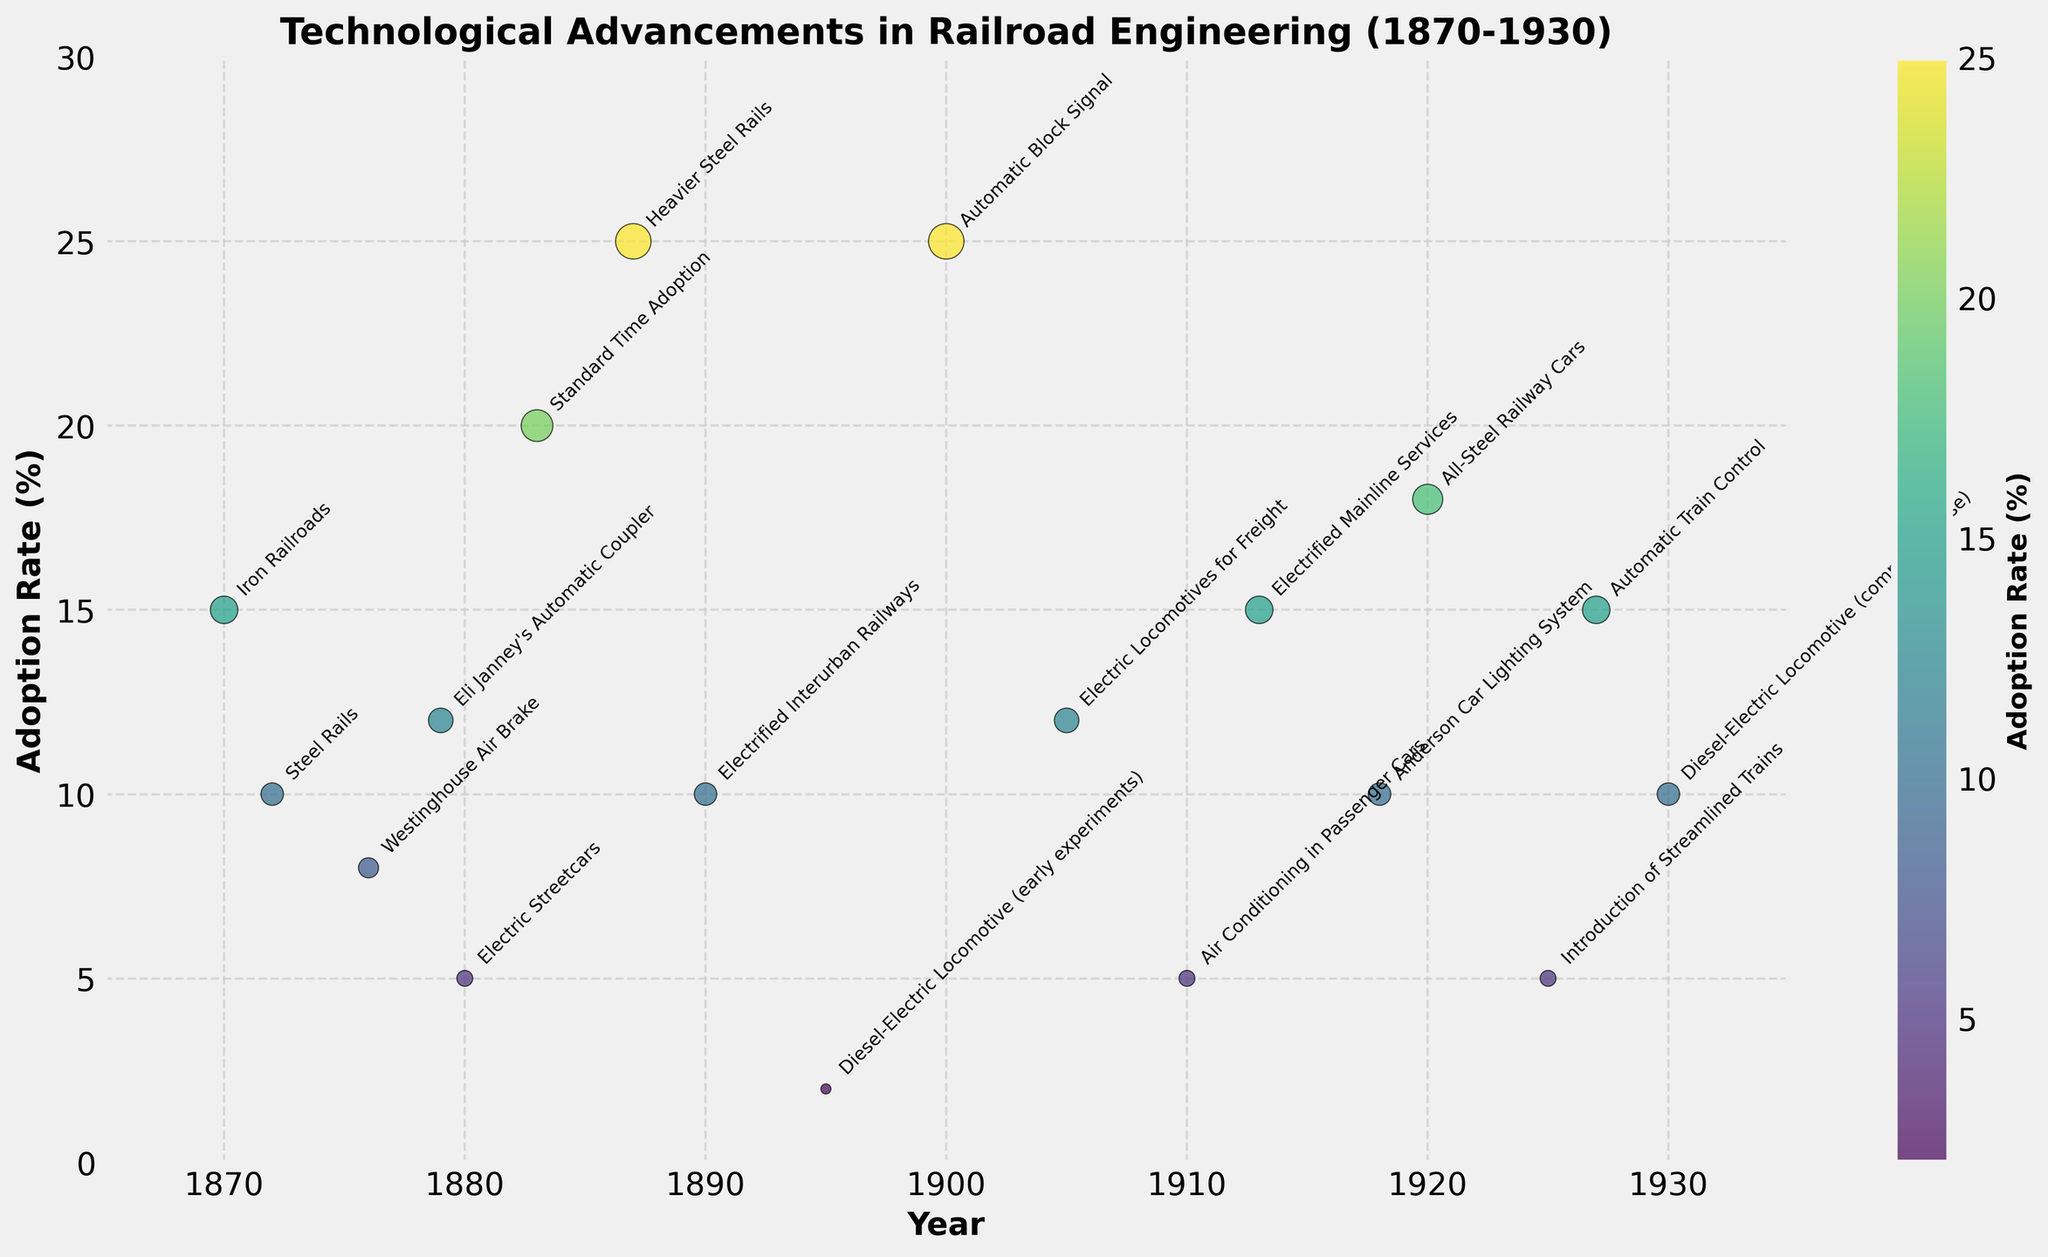What is the title of the figure? The title is usually located at the top of the figure. "Technological Advancements in Railroad Engineering (1870-1930)" is clearly indicated as the title.
Answer: Technological Advancements in Railroad Engineering (1870-1930) How many technological advancements are depicted in the figure? Counting all the data points annotated with their respective technological advancements shows there are 17 advancements.
Answer: 17 Which technological advancement had the highest adoption rate, and what was the rate? The highest adoption rate can be identified by looking for the data point with the maximum value on the y-axis. The "Heavier Steel Rails" in 1887 had the highest adoption rate at 25%.
Answer: Heavier Steel Rails, 25% What is the range of years shown on the x-axis? The x-axis starts slightly before 1870 and ends slightly after 1930. Checking the axis points confirms the range is from 1865 to 1935.
Answer: 1865 to 1935 Which year had the lowest adoption rate and what was the technological advancement during that year? By identifying the minimum value on the y-axis and checking corresponding annotations, 1895 had the lowest adoption rate of 2% for "Diesel-Electric Locomotive (early experiments)".
Answer: 1895, Diesel-Electric Locomotive (early experiments) How many technological advancements had an adoption rate of 10%? By checking the y-axis values, and identifying the data points at the 10% mark, there are four advancements: "Steel Rails" in 1872, "Electrified Interurban Railways" in 1890, "Anderson Car Lighting System" in 1918, and "Diesel-Electric Locomotive (commercial use)" in 1930.
Answer: 4 Which technological advancements spanned the years 1900 to 1910? Checking the year range between 1900 and 1910 and identifying the corresponding annotations, the advancements are "Automatic Block Signal" in 1900, "Electric Locomotives for Freight" in 1905, and "Air Conditioning in Passenger Cars" in 1910.
Answer: Automatic Block Signal (1900), Electric Locomotives for Freight (1905), Air Conditioning in Passenger Cars (1910) What is the average adoption rate for technological advancements between 1880 and 1900? Identify the adoption rates for advancements within the specified years: 20% (Standard Time Adoption in 1883), 25% (Heavier Steel Rails in 1887), 10% (Electrified Interurban Railways in 1890), and 2% (Diesel-Electric Locomotive in 1895). Sum these values and divide by the number of advancements: (20 + 25 + 10 + 2) / 4 = 57 / 4 = 14.25%.
Answer: 14.25% How does the adoption rate of "Automatic Train Control" in 1927 compare to "Electric Locomotives for Freight" in 1905? Compare the y-values for both years, where Automatic Train Control in 1927 has an adoption rate of 15% and Electric Locomotives for Freight in 1905 has an adoption rate of 12%. Automatic Train Control has a higher adoption rate.
Answer: Higher Which technological advancement had the same adoption rate as "Anderson Car Lighting System" in 1918? The adoption rate for Anderson Car Lighting System in 1918 is 10%. Comparing the y-values to find matching rates, "Steel Rails" in 1872, "Electrified Interurban Railways" in 1890, and "Diesel-Electric Locomotive (commercial use)" in 1930 all had the same adoption rate of 10%.
Answer: Steel Rails (1872), Electrified Interurban Railways (1890), Diesel-Electric Locomotive (commercial use) (1930) 